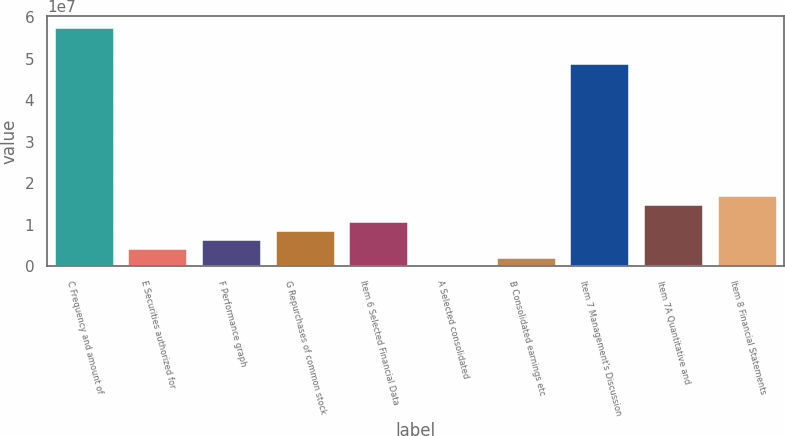Convert chart to OTSL. <chart><loc_0><loc_0><loc_500><loc_500><bar_chart><fcel>C Frequency and amount of<fcel>E Securities authorized for<fcel>F Performance graph<fcel>G Repurchases of common stock<fcel>Item 6 Selected Financial Data<fcel>A Selected consolidated<fcel>B Consolidated earnings etc<fcel>Item 7 Management's Discussion<fcel>Item 7A Quantitative and<fcel>Item 8 Financial Statements<nl><fcel>5.73188e+07<fcel>4.24586e+06<fcel>6.36877e+06<fcel>8.49169e+06<fcel>1.06146e+07<fcel>20<fcel>2.12294e+06<fcel>4.88271e+07<fcel>1.48604e+07<fcel>1.69834e+07<nl></chart> 